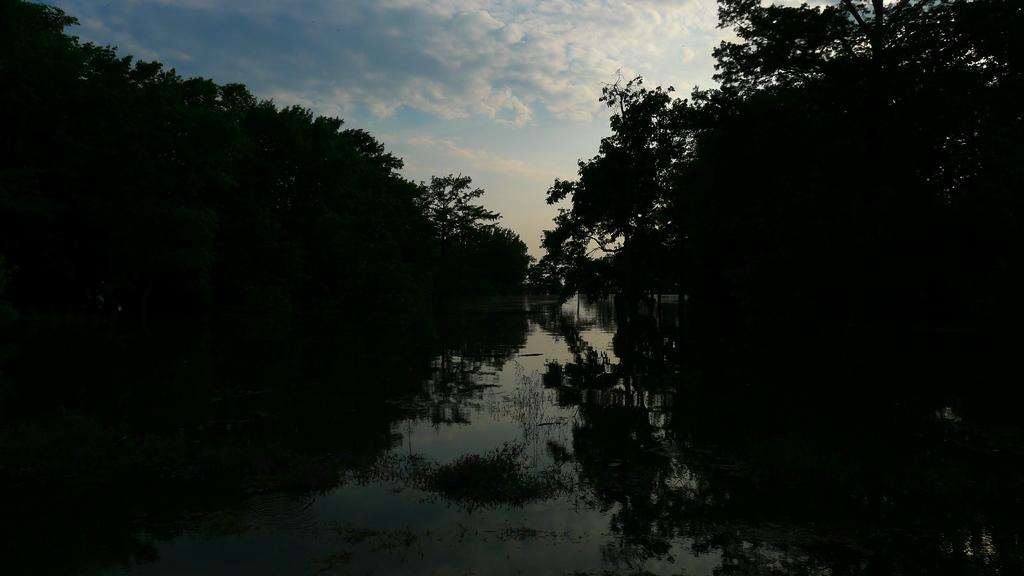What is the primary element visible in the image? There is water in the image. What type of natural vegetation can be seen in the image? There are trees in the image. What type of structure is present in the image? There is a house in the image. What part of the natural environment is visible in the image? The sky is visible in the image. What might be the location of the image, based on the presence of water? The image may have been taken near a lake, given the presence of water. What type of vase is present in the image? There is no vase present in the image. Is the house in the image a prison? No, the house in the image is not a prison; it is a residential structure. 